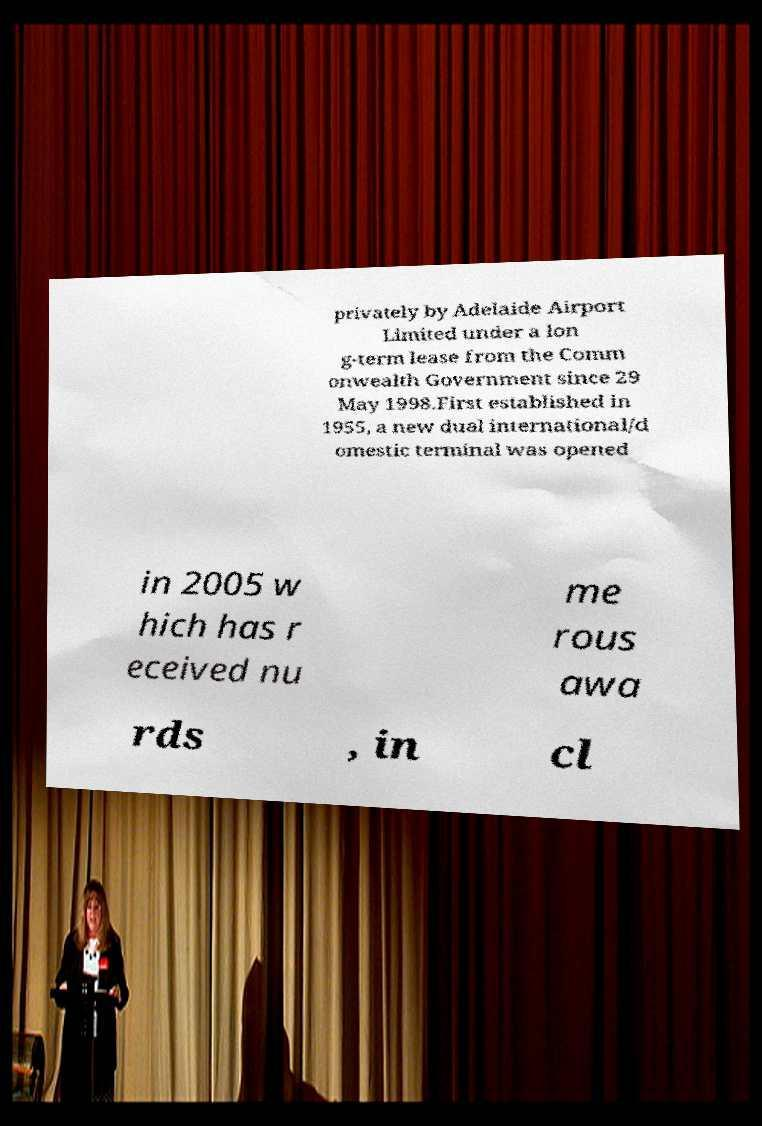What messages or text are displayed in this image? I need them in a readable, typed format. privately by Adelaide Airport Limited under a lon g-term lease from the Comm onwealth Government since 29 May 1998.First established in 1955, a new dual international/d omestic terminal was opened in 2005 w hich has r eceived nu me rous awa rds , in cl 